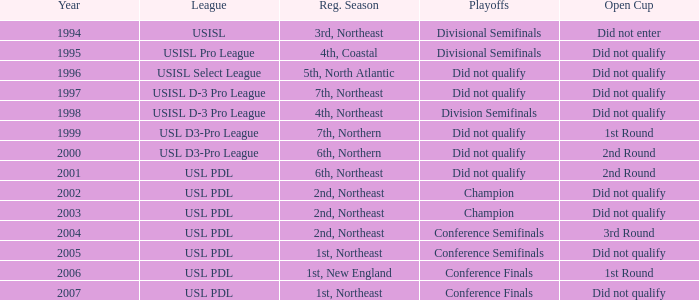Specify the count of playoffs in the 3rd round. 1.0. 